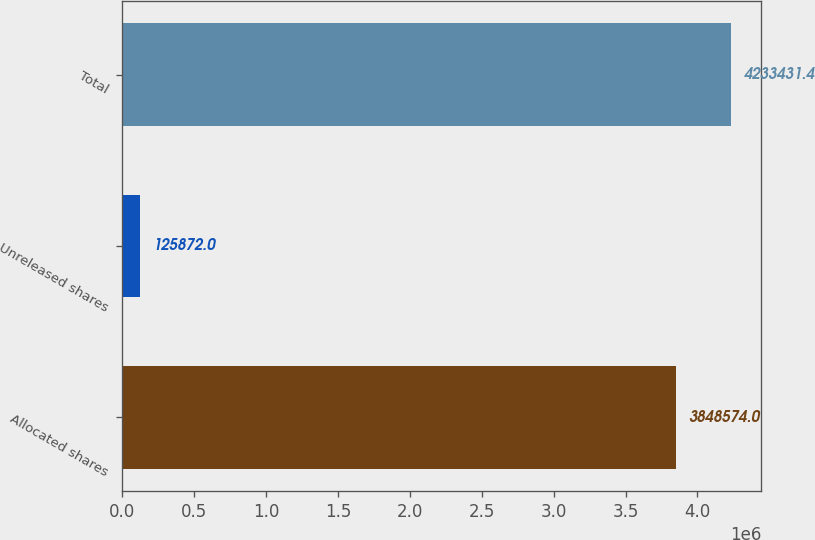Convert chart to OTSL. <chart><loc_0><loc_0><loc_500><loc_500><bar_chart><fcel>Allocated shares<fcel>Unreleased shares<fcel>Total<nl><fcel>3.84857e+06<fcel>125872<fcel>4.23343e+06<nl></chart> 